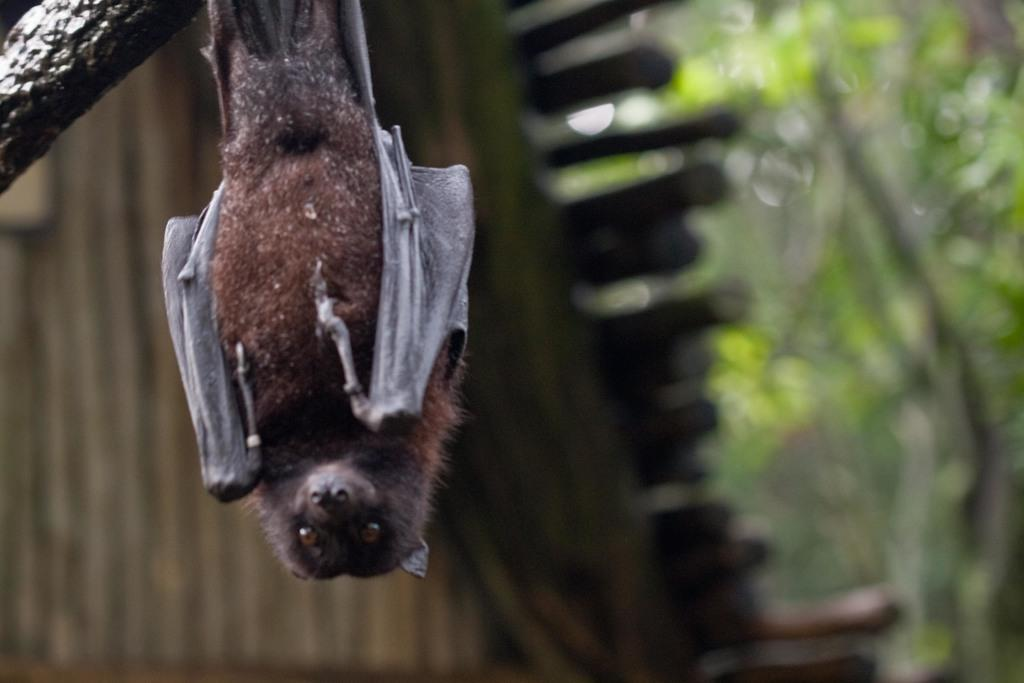Where was the picture taken? The picture was clicked outside. What can be seen hanging on a tree branch in the image? There is a bat hanging on a tree branch in the image. What is the color of the leaves on the tree? The tree has green leaves. What else can be seen in the background of the image? There are other objects visible in the background. What type of yarn is the rabbit using to knit a sweater in the image? There is no rabbit or yarn present in the image; it features a bat hanging on a tree branch. How many planes can be seen flying in the sky in the image? There are no planes visible in the image; it was taken outside with a focus on the bat and tree. 